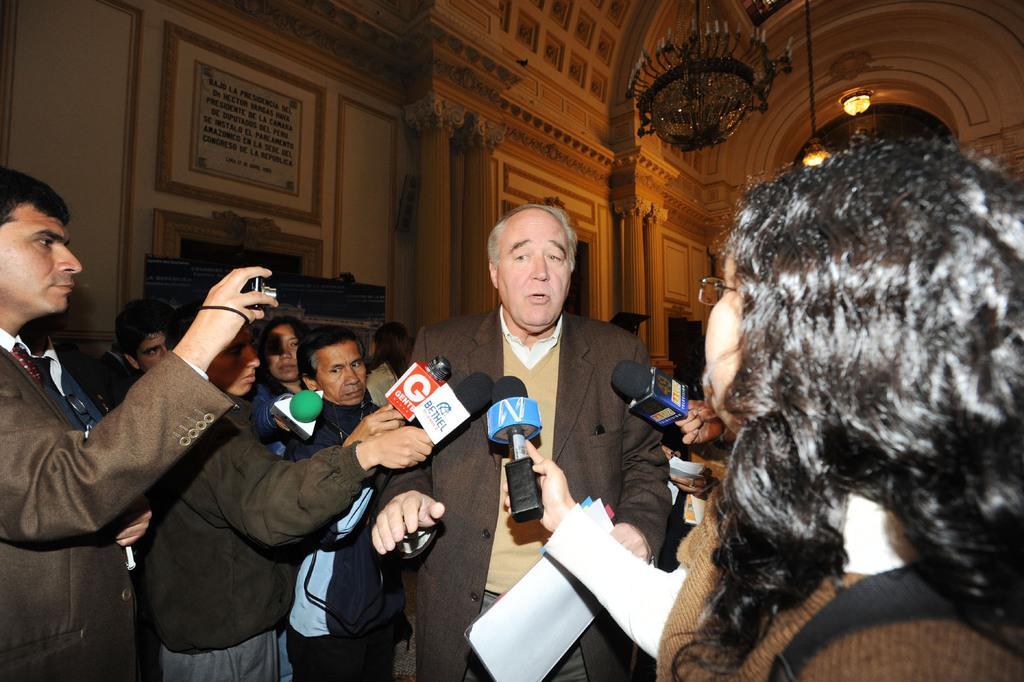Describe this image in one or two sentences. This image is taken indoors. In the background there are a few walls with carvings. There are a few pillars. There are a few picture frames and there is a board with a text on it. At the top of the image there is a roof and there is a chandelier and there are two lamps. On the right side of the image there are a few people standing and holding mics in their hands. In the middle of the image a man is minor standing and talking. He is holding a paper in his hand. On the left side of the image a few people are standing and they are holding mics in their hands and a man is holding a camera in his hand and clicking pictures. 